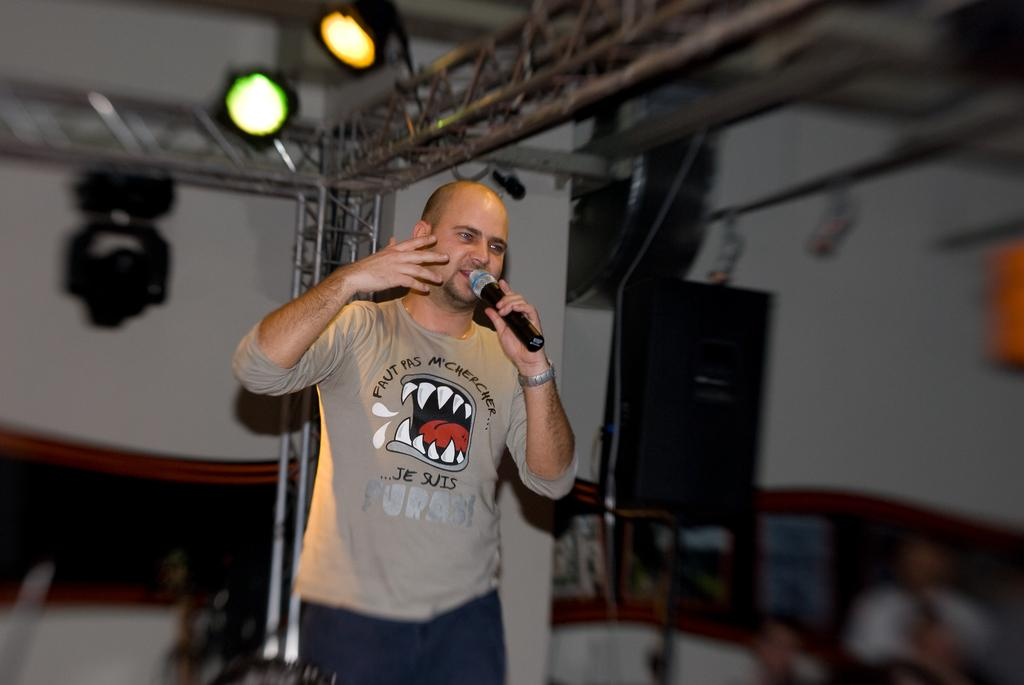What is the person in the image doing? The person is standing in the image and holding a microphone. What objects can be seen at the top of the image? There are lights at the top of the image. How would you describe the background of the image? The background of the image is blurred. Can you see a hospital or a crown in the image? No, there is no hospital or crown present in the image. 